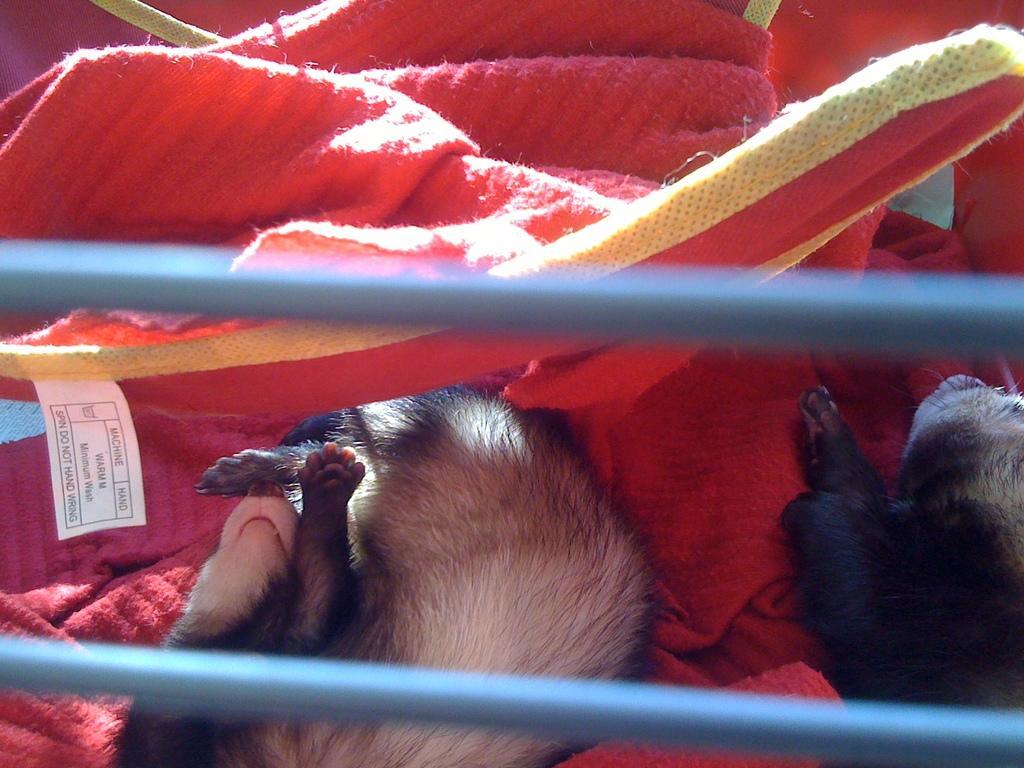Can you describe this image briefly? This is a zoomed in picture. In the foreground we can see the cables and two animals seems to be lying on a red color object. In the background we can see the red color cloth. 